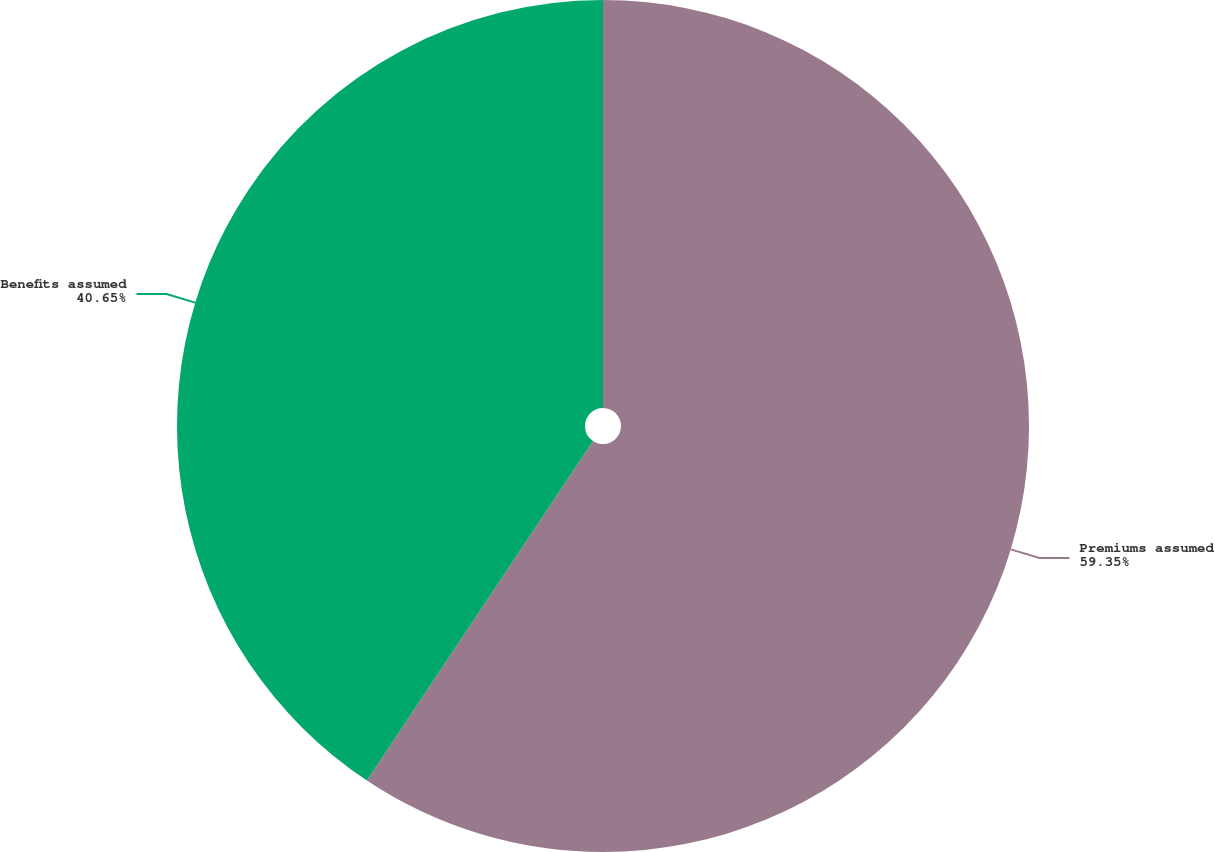<chart> <loc_0><loc_0><loc_500><loc_500><pie_chart><fcel>Premiums assumed<fcel>Benefits assumed<nl><fcel>59.35%<fcel>40.65%<nl></chart> 